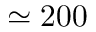<formula> <loc_0><loc_0><loc_500><loc_500>\simeq 2 0 0</formula> 